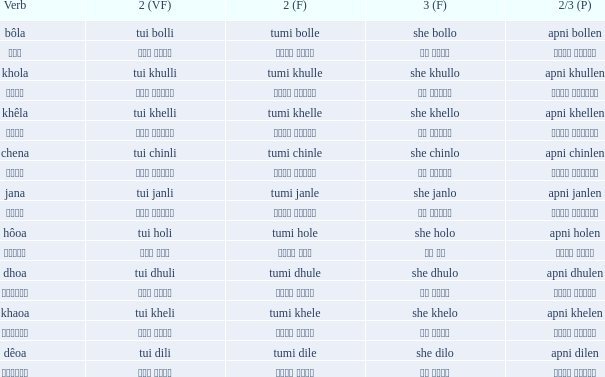What is the verb for Khola? She khullo. 